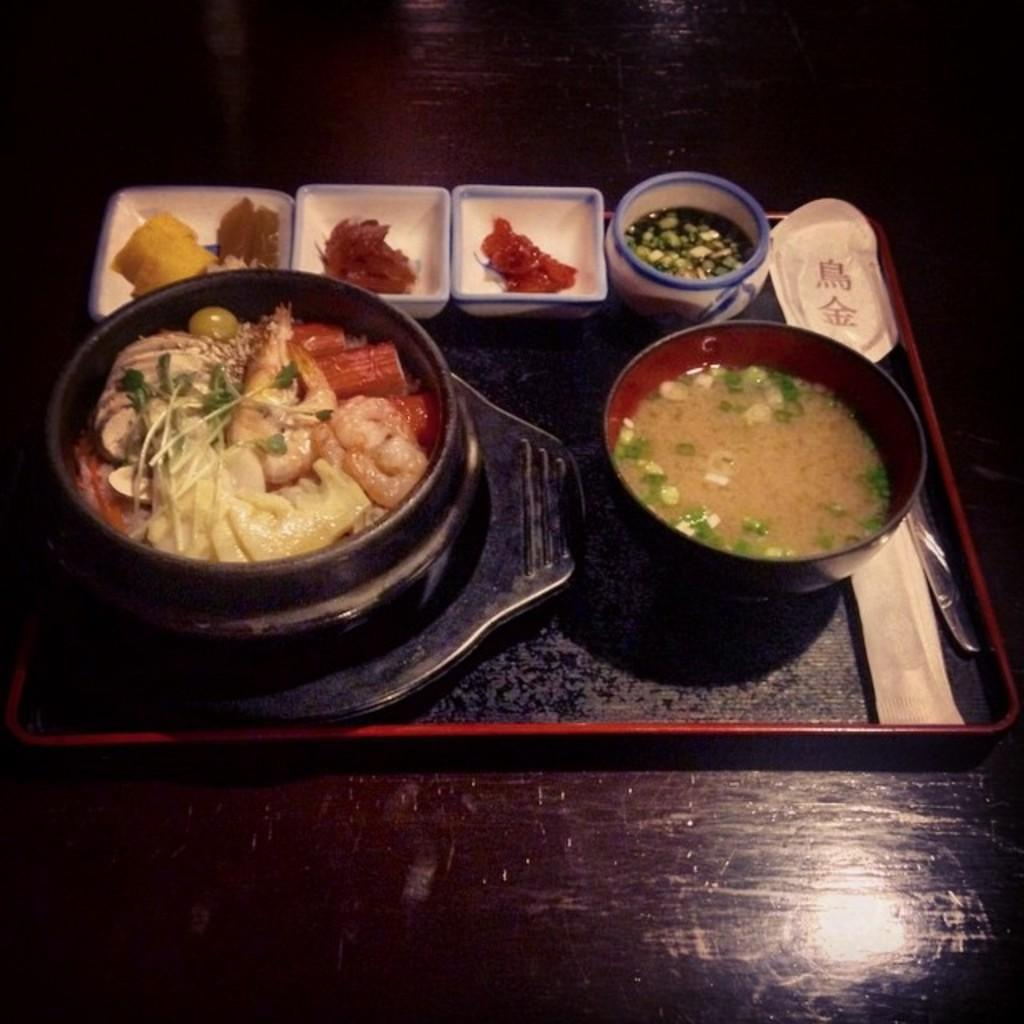What type of food items can be seen in the image? There are food items in bowls in the image. How are the food items arranged in the image? The food items are arranged on a tray. What is the surface on which the tray is placed in the image? There is a table at the bottom of the image. What is the price of the food items on the tray in the image? The image does not provide any information about the price of the food items. 